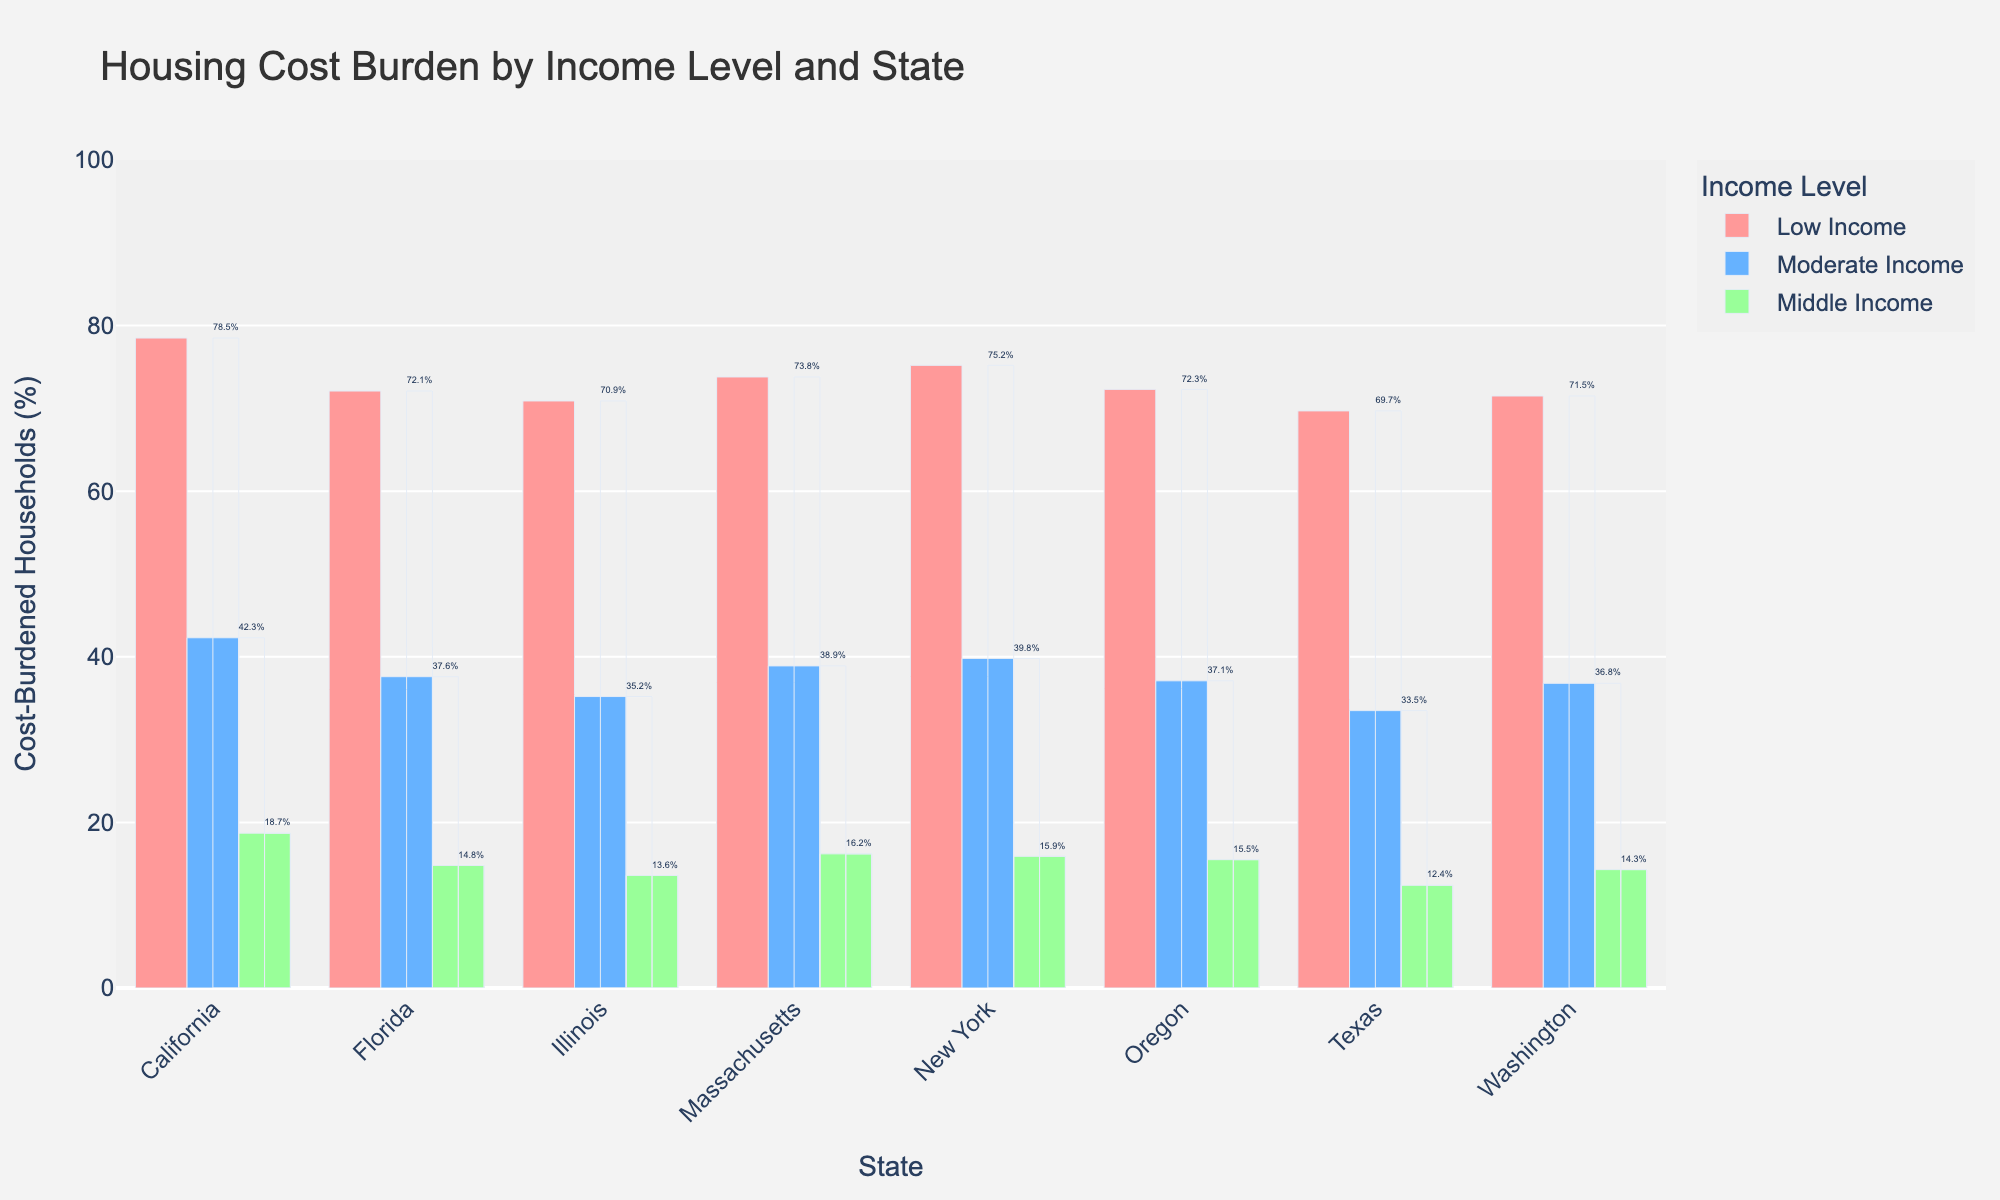Which state has the highest percentage of cost-burdened households among low income earners? The visual graph shows different colors representing distinct income levels. By looking at the red bars (which represent low income), California has the tallest bar, indicating the highest percentage.
Answer: California Which state has the lowest percentage of cost-burdened households among middle income earners? Observing the green bars (which represent middle income), Texas has the shortest bar, indicating the lowest percentage.
Answer: Texas Between California and New York, which state has a higher percentage of cost-burdened households among moderate income earners? Comparatively looking at the blue bars (which represent moderate income) for both states, California has a higher percentage than New York.
Answer: California What is the difference in the percentage of cost-burdened households between low and middle income earners in Massachusetts? Observe the red bar (low income, 73.8%) and the green bar (middle income, 16.2%) in Massachusetts. Subtract the percentage for middle income from that of low income: 73.8% - 16.2% = 57.6%.
Answer: 57.6% Which state has the smallest range between low and moderate income earners in terms of cost burden percentage? To find the range for each state, subtract the moderate income percentage from the low income percentage. The state with the smallest value is Texas: 69.7% - 33.5% = 36.2%.
Answer: Texas What is the average percentage of cost-burdened households for moderate income earners across all states? Sum the percentages of cost-burdened households for moderate income earners in each state and divide by the number of states: (42.3 + 39.8 + 33.5 + 37.6 + 35.2 + 38.9 + 36.8 + 37.1) / 8 ≈ 37.7%.
Answer: 37.7% Which income level generally experiences the highest housing cost burden across all states? By looking at the bar heights, red bars (low income) are generally the tallest across all states, indicating the highest housing cost burden.
Answer: Low Income How does the percentage difference in cost burden between low and moderate income earners in Oregon compare to that in Illinois? Calculate the differences for both states: Oregon: 72.3% - 37.1% = 35.2%, Illinois: 70.9% - 35.2% = 35.7%. By comparing the two, it is found that the difference is greater in Illinois.
Answer: Illinois 